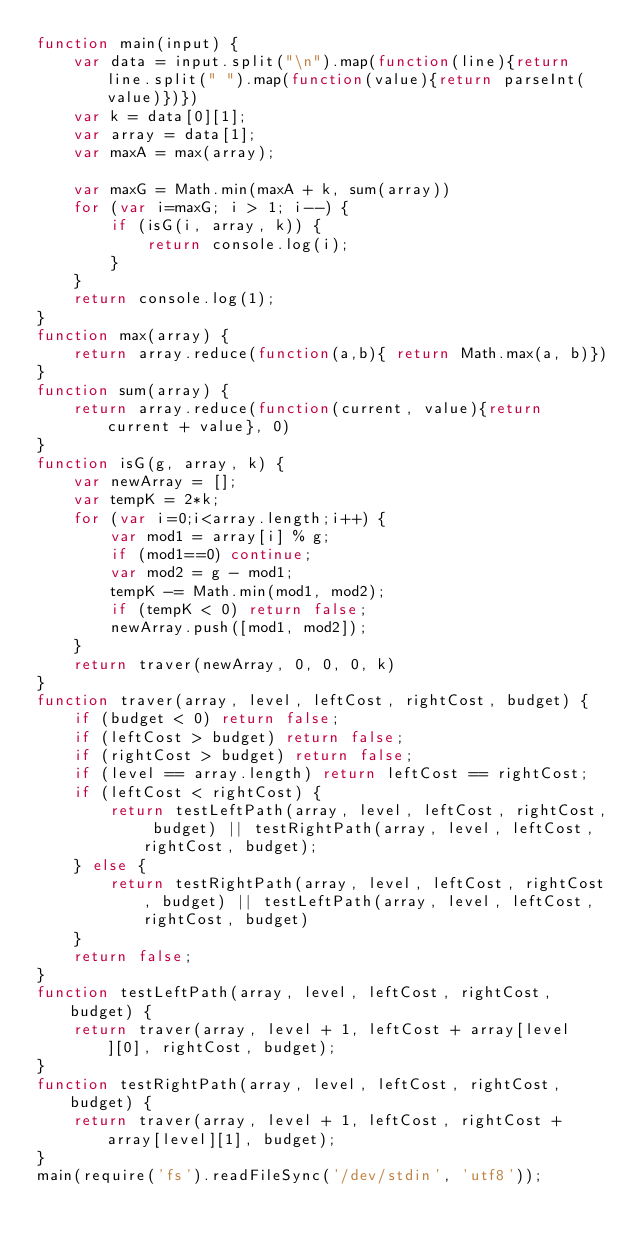Convert code to text. <code><loc_0><loc_0><loc_500><loc_500><_JavaScript_>function main(input) {
    var data = input.split("\n").map(function(line){return line.split(" ").map(function(value){return parseInt(value)})})
    var k = data[0][1];
    var array = data[1];
    var maxA = max(array);

    var maxG = Math.min(maxA + k, sum(array))
    for (var i=maxG; i > 1; i--) {
    	if (isG(i, array, k)) {
    		return console.log(i);
    	}
    }
    return console.log(1);
}
function max(array) {
	return array.reduce(function(a,b){ return Math.max(a, b)})
}
function sum(array) {
	return array.reduce(function(current, value){return current + value}, 0)
}
function isG(g, array, k) {
	var newArray = [];
	var tempK = 2*k;
	for (var i=0;i<array.length;i++) {
		var mod1 = array[i] % g;
		if (mod1==0) continue;
		var mod2 = g - mod1;
		tempK -= Math.min(mod1, mod2);
		if (tempK < 0) return false;
		newArray.push([mod1, mod2]);
	}
	return traver(newArray, 0, 0, 0, k)
}
function traver(array, level, leftCost, rightCost, budget) {
	if (budget < 0) return false;
	if (leftCost > budget) return false;
	if (rightCost > budget) return false;
	if (level == array.length) return leftCost == rightCost;
	if (leftCost < rightCost) {
		return testLeftPath(array, level, leftCost, rightCost, budget) || testRightPath(array, level, leftCost, rightCost, budget);
	} else {
		return testRightPath(array, level, leftCost, rightCost, budget) || testLeftPath(array, level, leftCost, rightCost, budget)
	}
	return false;
}
function testLeftPath(array, level, leftCost, rightCost, budget) {
	return traver(array, level + 1, leftCost + array[level][0], rightCost, budget);
}
function testRightPath(array, level, leftCost, rightCost, budget) {
	return traver(array, level + 1, leftCost, rightCost + array[level][1], budget);
}
main(require('fs').readFileSync('/dev/stdin', 'utf8'));</code> 